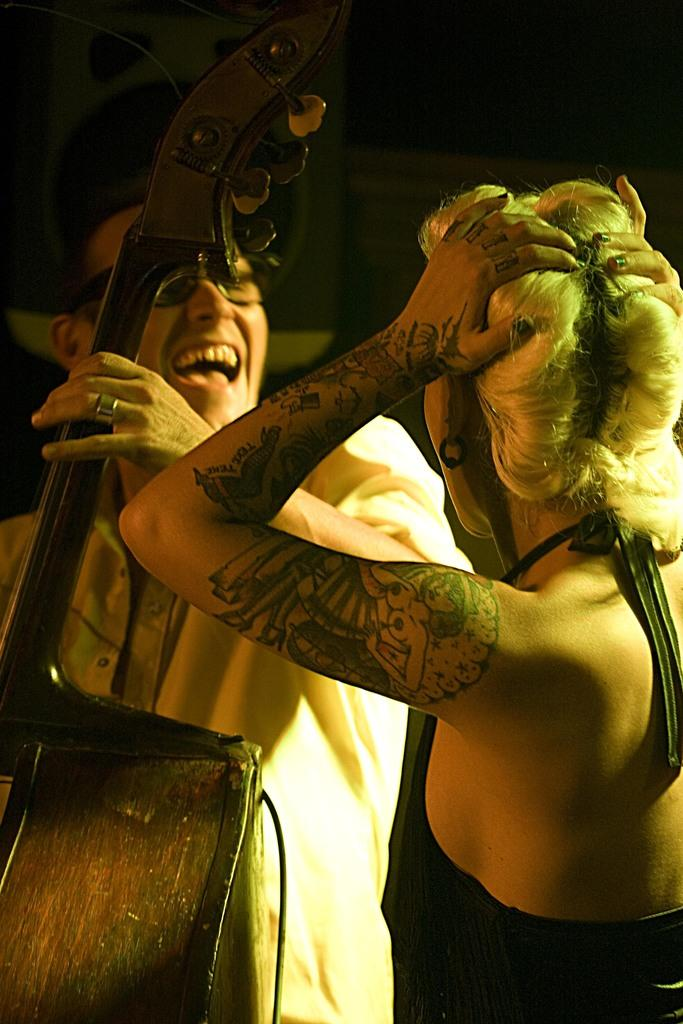How many people are present in the image? There is a man and a woman in the image. What is the man holding in the image? The man is holding a musical instrument. What can be seen in the background of the image? There is a wooden stand and a wire in the image. What type of scent can be detected from the icicle in the image? There is no icicle present in the image, so it is not possible to detect any scent from it. 